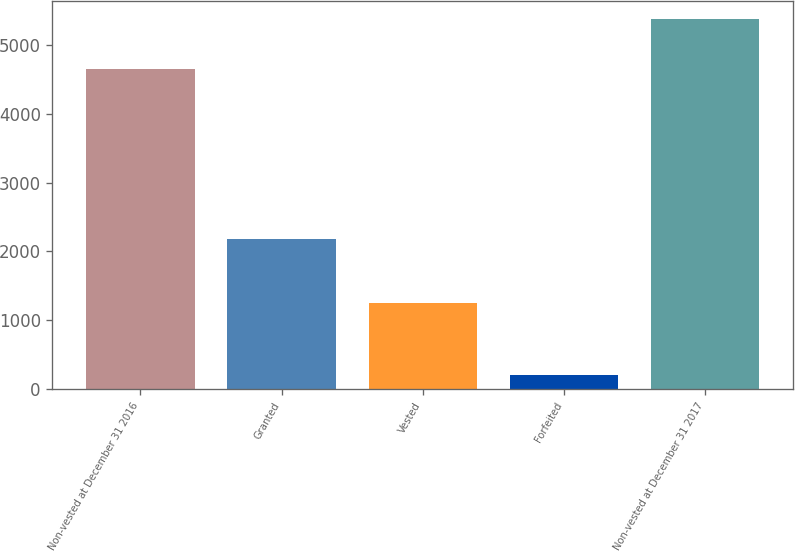<chart> <loc_0><loc_0><loc_500><loc_500><bar_chart><fcel>Non-vested at December 31 2016<fcel>Granted<fcel>Vested<fcel>Forfeited<fcel>Non-vested at December 31 2017<nl><fcel>4653<fcel>2176<fcel>1253<fcel>209<fcel>5367<nl></chart> 